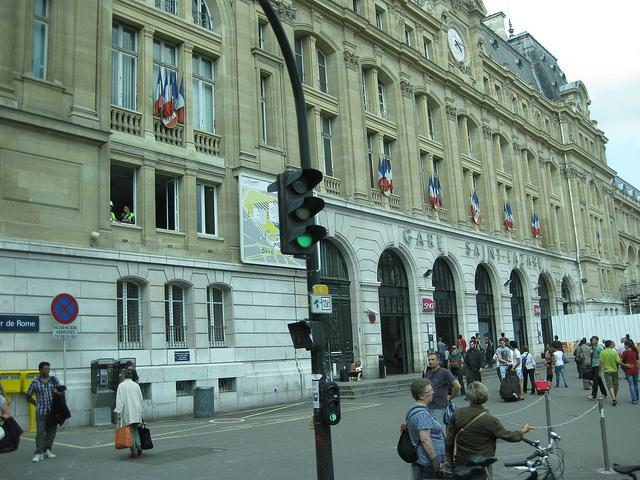What actress was born in this country?

Choices:
A) jennifer connelly
B) adele haenel
C) margaret qualley
D) brooke shields adele haenel 